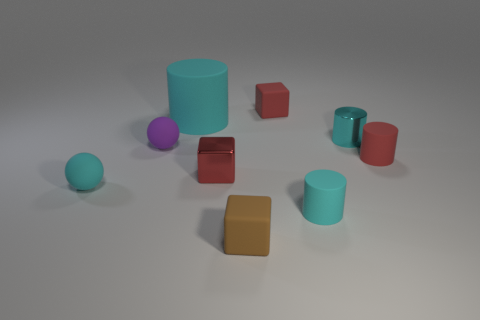The cyan metallic object that is the same size as the purple rubber object is what shape?
Give a very brief answer. Cylinder. What number of rubber objects are either big cyan objects or small purple things?
Your answer should be compact. 2. Is the material of the cylinder in front of the small red shiny object the same as the block that is to the right of the brown rubber block?
Ensure brevity in your answer.  Yes. There is another sphere that is the same material as the tiny cyan ball; what is its color?
Offer a very short reply. Purple. Is the number of tiny matte things that are to the left of the red matte block greater than the number of tiny red cubes in front of the brown matte block?
Ensure brevity in your answer.  Yes. Are there any small cyan cylinders?
Provide a short and direct response. Yes. How many things are red things or cyan cylinders?
Keep it short and to the point. 6. Is there a tiny metallic object of the same color as the large object?
Your answer should be very brief. Yes. What number of big cyan matte cylinders are behind the small red block to the right of the small brown thing?
Offer a very short reply. 0. Is the number of tiny green spheres greater than the number of large cyan cylinders?
Provide a short and direct response. No. 